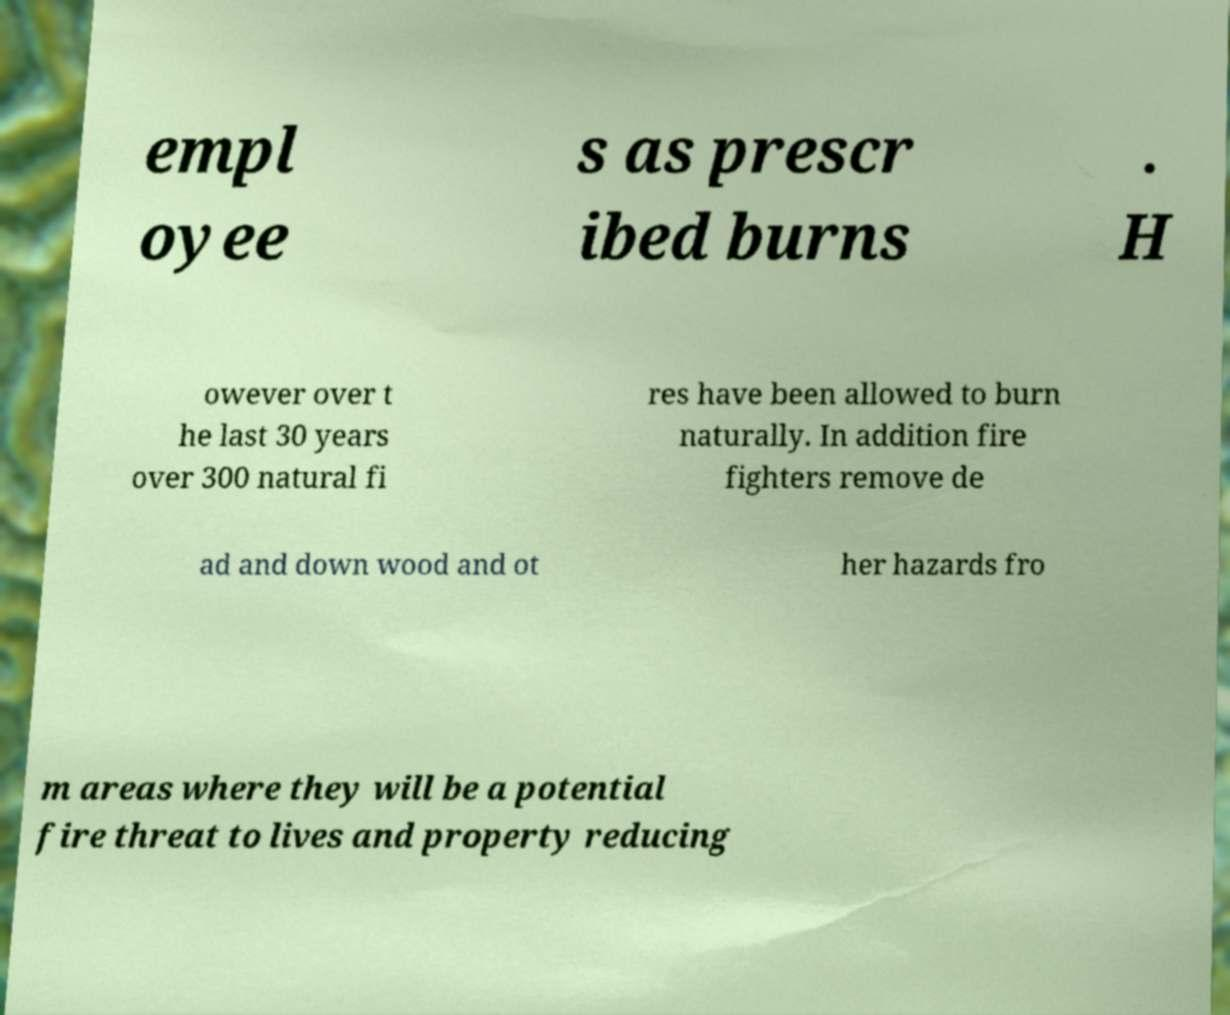Could you extract and type out the text from this image? empl oyee s as prescr ibed burns . H owever over t he last 30 years over 300 natural fi res have been allowed to burn naturally. In addition fire fighters remove de ad and down wood and ot her hazards fro m areas where they will be a potential fire threat to lives and property reducing 